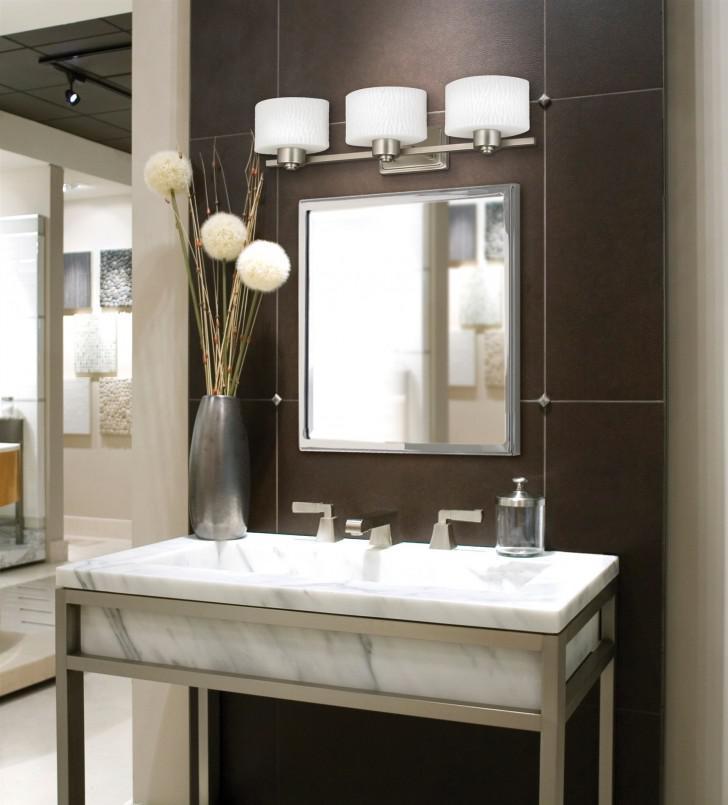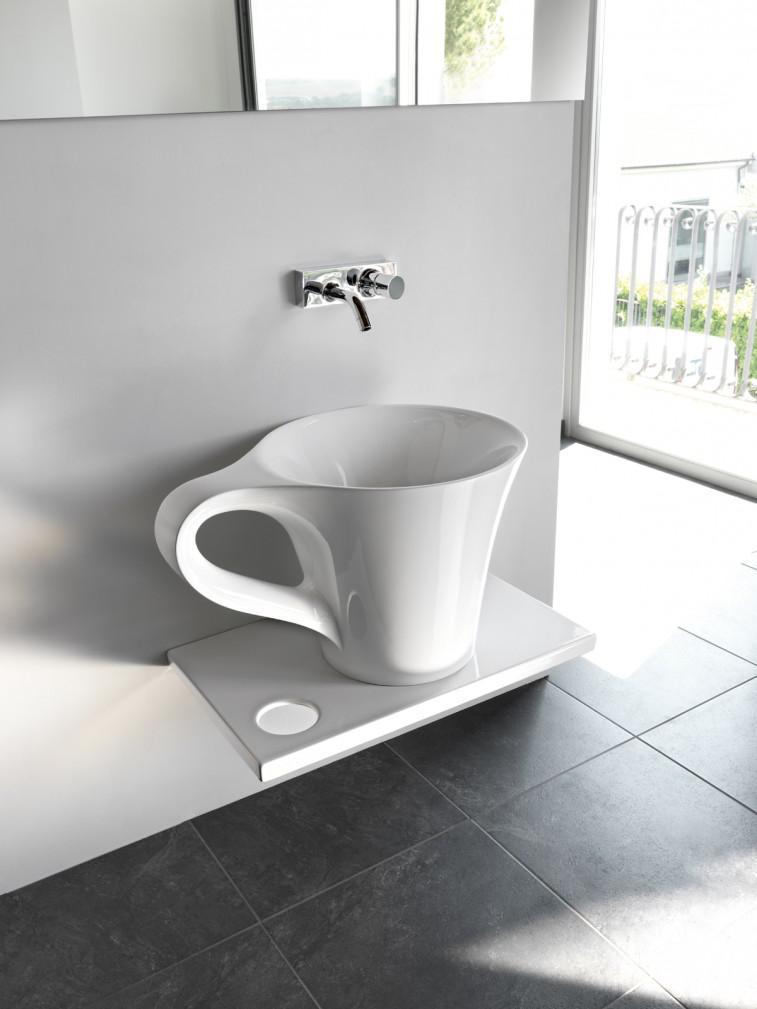The first image is the image on the left, the second image is the image on the right. Analyze the images presented: Is the assertion "A sink is in the shape of a cup." valid? Answer yes or no. Yes. 